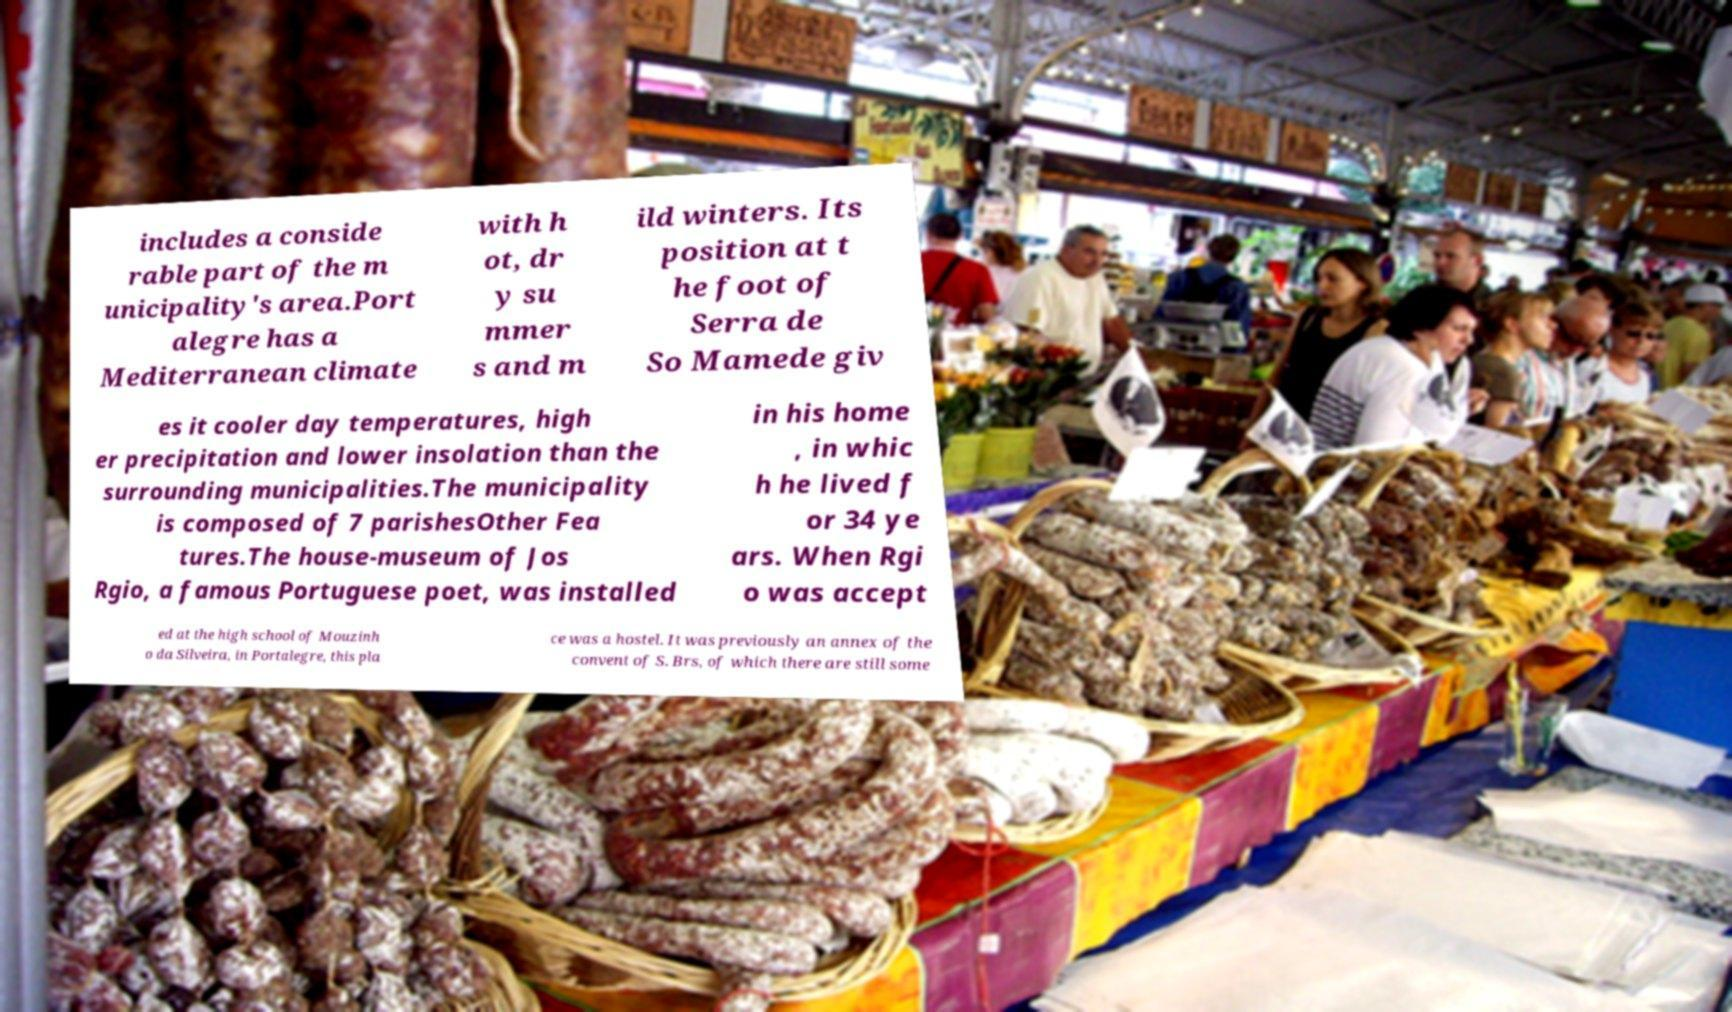What messages or text are displayed in this image? I need them in a readable, typed format. includes a conside rable part of the m unicipality's area.Port alegre has a Mediterranean climate with h ot, dr y su mmer s and m ild winters. Its position at t he foot of Serra de So Mamede giv es it cooler day temperatures, high er precipitation and lower insolation than the surrounding municipalities.The municipality is composed of 7 parishesOther Fea tures.The house-museum of Jos Rgio, a famous Portuguese poet, was installed in his home , in whic h he lived f or 34 ye ars. When Rgi o was accept ed at the high school of Mouzinh o da Silveira, in Portalegre, this pla ce was a hostel. It was previously an annex of the convent of S. Brs, of which there are still some 